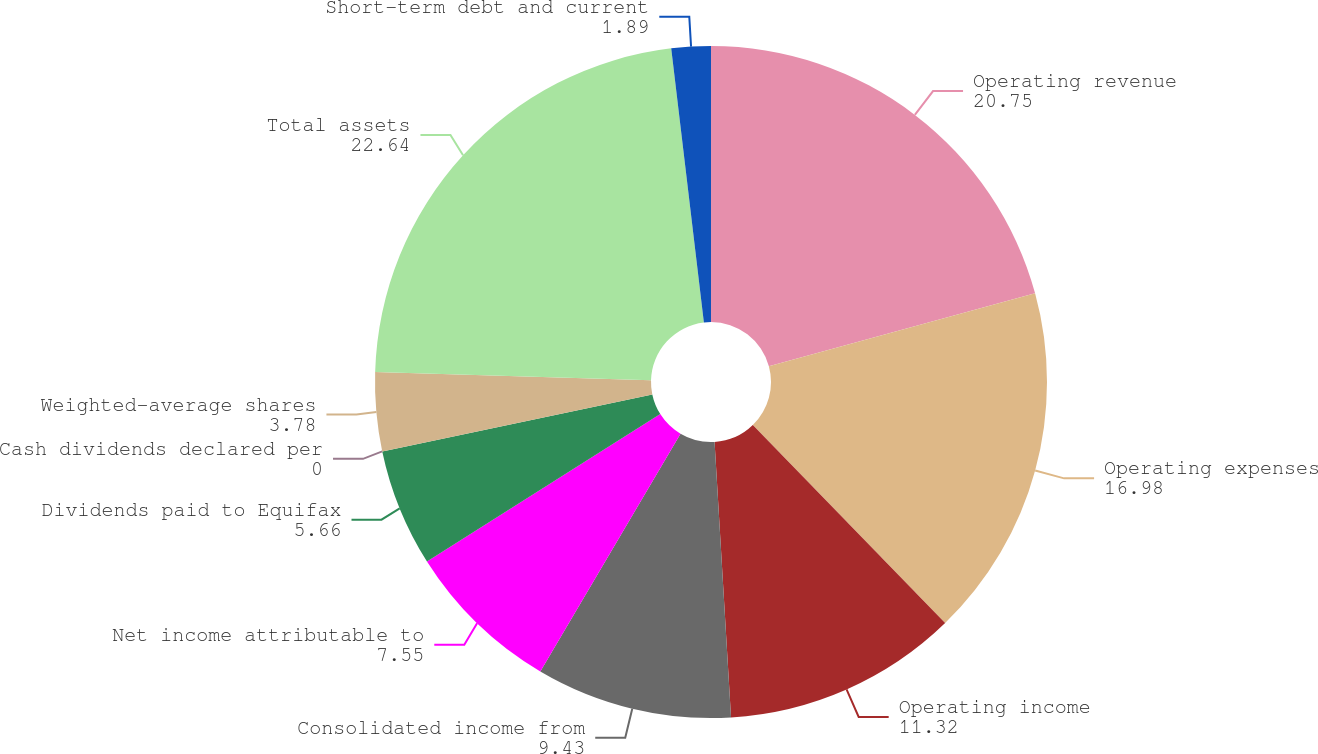Convert chart to OTSL. <chart><loc_0><loc_0><loc_500><loc_500><pie_chart><fcel>Operating revenue<fcel>Operating expenses<fcel>Operating income<fcel>Consolidated income from<fcel>Net income attributable to<fcel>Dividends paid to Equifax<fcel>Cash dividends declared per<fcel>Weighted-average shares<fcel>Total assets<fcel>Short-term debt and current<nl><fcel>20.75%<fcel>16.98%<fcel>11.32%<fcel>9.43%<fcel>7.55%<fcel>5.66%<fcel>0.0%<fcel>3.78%<fcel>22.64%<fcel>1.89%<nl></chart> 